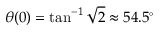Convert formula to latex. <formula><loc_0><loc_0><loc_500><loc_500>\theta ( 0 ) = \tan ^ { - 1 } { \sqrt { 2 } } \approx 5 4 . 5 ^ { \circ }</formula> 